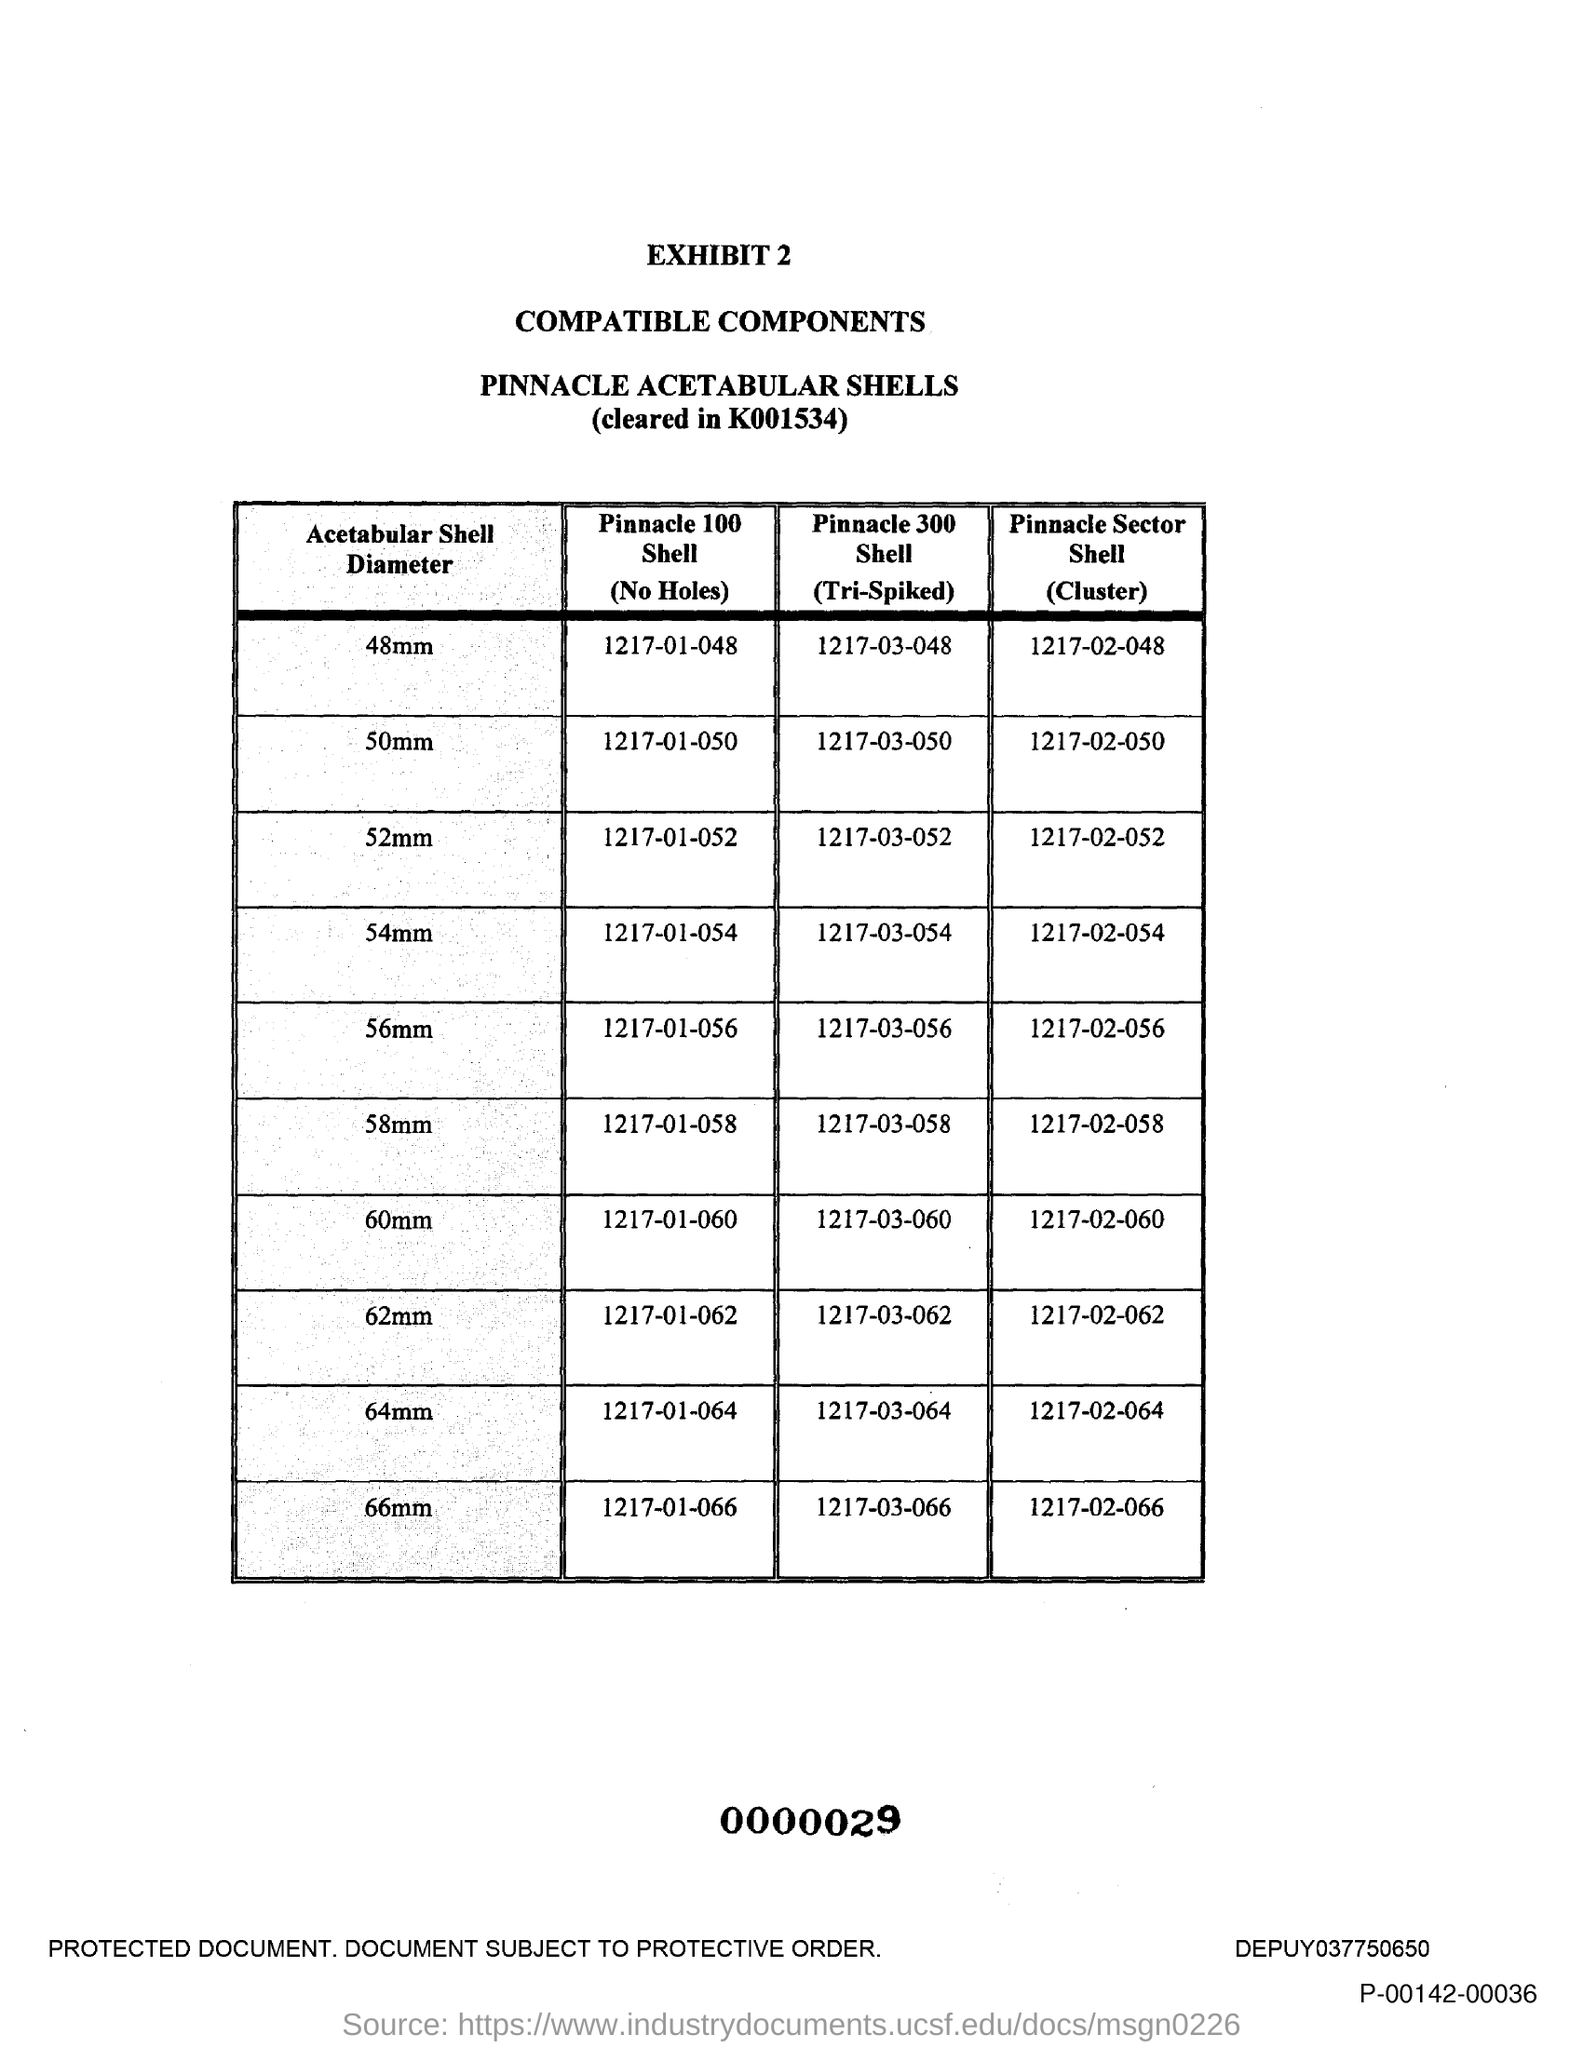What is the Pinnacle 100 shell (No Holes) for 48mm?
Make the answer very short. 1217-01-048. What is the Pinnacle 100 shell (No Holes) for 50mm?
Provide a succinct answer. 1217-01-050. What is the Pinnacle 100 shell (No Holes) for 52mm?
Make the answer very short. 1217-01-052. What is the Pinnacle 100 shell (No Holes) for 54mm?
Your answer should be very brief. 1217-01-054. What is the Pinnacle 100 shell (No Holes) for 56mm?
Offer a terse response. 1217-01-056. What is the Pinnacle 100 shell (No Holes) for 58mm?
Ensure brevity in your answer.  1217-01-058. What is the Pinnacle 100 shell (No Holes) for 60mm?
Ensure brevity in your answer.  1217-01-060. What is the Pinnacle 100 shell (No Holes) for 62mm?
Give a very brief answer. 1217-01-062. What is the Pinnacle 100 shell (No Holes) for 64mm?
Offer a terse response. 1217-01-064. What is the Pinnacle 100 shell (No Holes) for 66mm?
Your answer should be compact. 1217-01-066. 